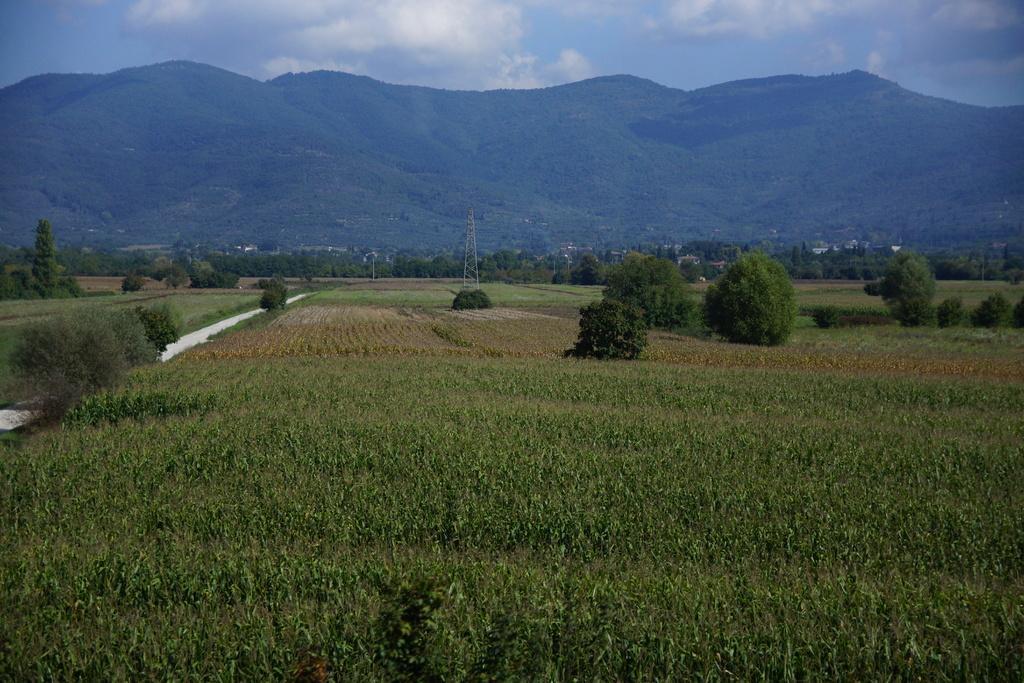In one or two sentences, can you explain what this image depicts? In this image we can see sky with clouds, hills, buildings, electric tower, agricultural farms and bushes. 